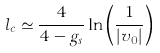<formula> <loc_0><loc_0><loc_500><loc_500>l _ { c } \simeq { \frac { 4 } { 4 - g _ { s } } } \ln \left ( { \frac { 1 } { | v _ { 0 } | } } \right )</formula> 